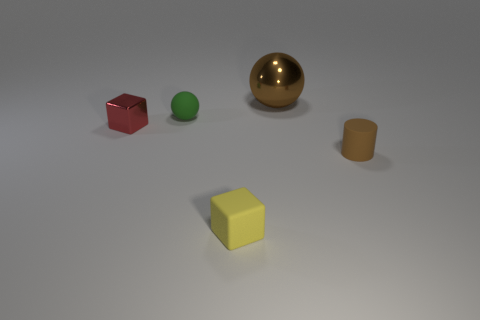Subtract all yellow cubes. How many cubes are left? 1 Subtract all spheres. How many objects are left? 3 Add 3 large shiny objects. How many objects exist? 8 Subtract 1 cylinders. How many cylinders are left? 0 Subtract all cyan spheres. Subtract all brown cylinders. How many spheres are left? 2 Subtract all purple blocks. How many brown spheres are left? 1 Subtract all tiny green spheres. Subtract all small rubber cubes. How many objects are left? 3 Add 3 small yellow matte cubes. How many small yellow matte cubes are left? 4 Add 1 rubber things. How many rubber things exist? 4 Subtract 1 brown balls. How many objects are left? 4 